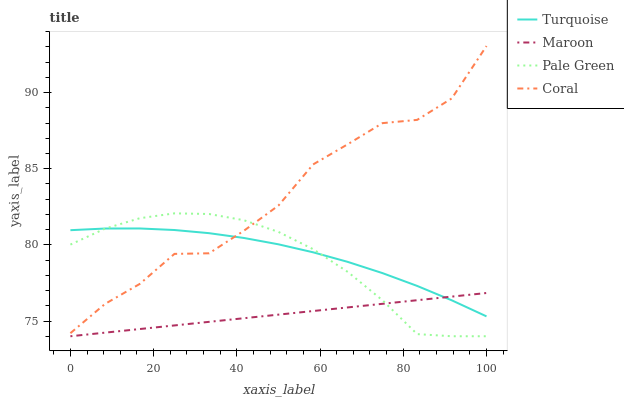Does Maroon have the minimum area under the curve?
Answer yes or no. Yes. Does Coral have the maximum area under the curve?
Answer yes or no. Yes. Does Pale Green have the minimum area under the curve?
Answer yes or no. No. Does Pale Green have the maximum area under the curve?
Answer yes or no. No. Is Maroon the smoothest?
Answer yes or no. Yes. Is Coral the roughest?
Answer yes or no. Yes. Is Pale Green the smoothest?
Answer yes or no. No. Is Pale Green the roughest?
Answer yes or no. No. Does Pale Green have the lowest value?
Answer yes or no. Yes. Does Coral have the lowest value?
Answer yes or no. No. Does Coral have the highest value?
Answer yes or no. Yes. Does Pale Green have the highest value?
Answer yes or no. No. Is Maroon less than Coral?
Answer yes or no. Yes. Is Coral greater than Maroon?
Answer yes or no. Yes. Does Maroon intersect Turquoise?
Answer yes or no. Yes. Is Maroon less than Turquoise?
Answer yes or no. No. Is Maroon greater than Turquoise?
Answer yes or no. No. Does Maroon intersect Coral?
Answer yes or no. No. 